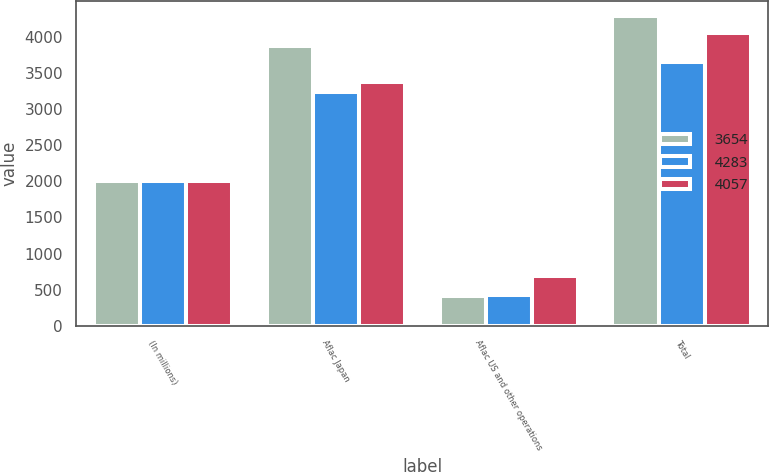Convert chart to OTSL. <chart><loc_0><loc_0><loc_500><loc_500><stacked_bar_chart><ecel><fcel>(In millions)<fcel>Aflac Japan<fcel>Aflac US and other operations<fcel>Total<nl><fcel>3654<fcel>2008<fcel>3874<fcel>409<fcel>4283<nl><fcel>4283<fcel>2007<fcel>3231<fcel>423<fcel>3654<nl><fcel>4057<fcel>2006<fcel>3372<fcel>685<fcel>4057<nl></chart> 